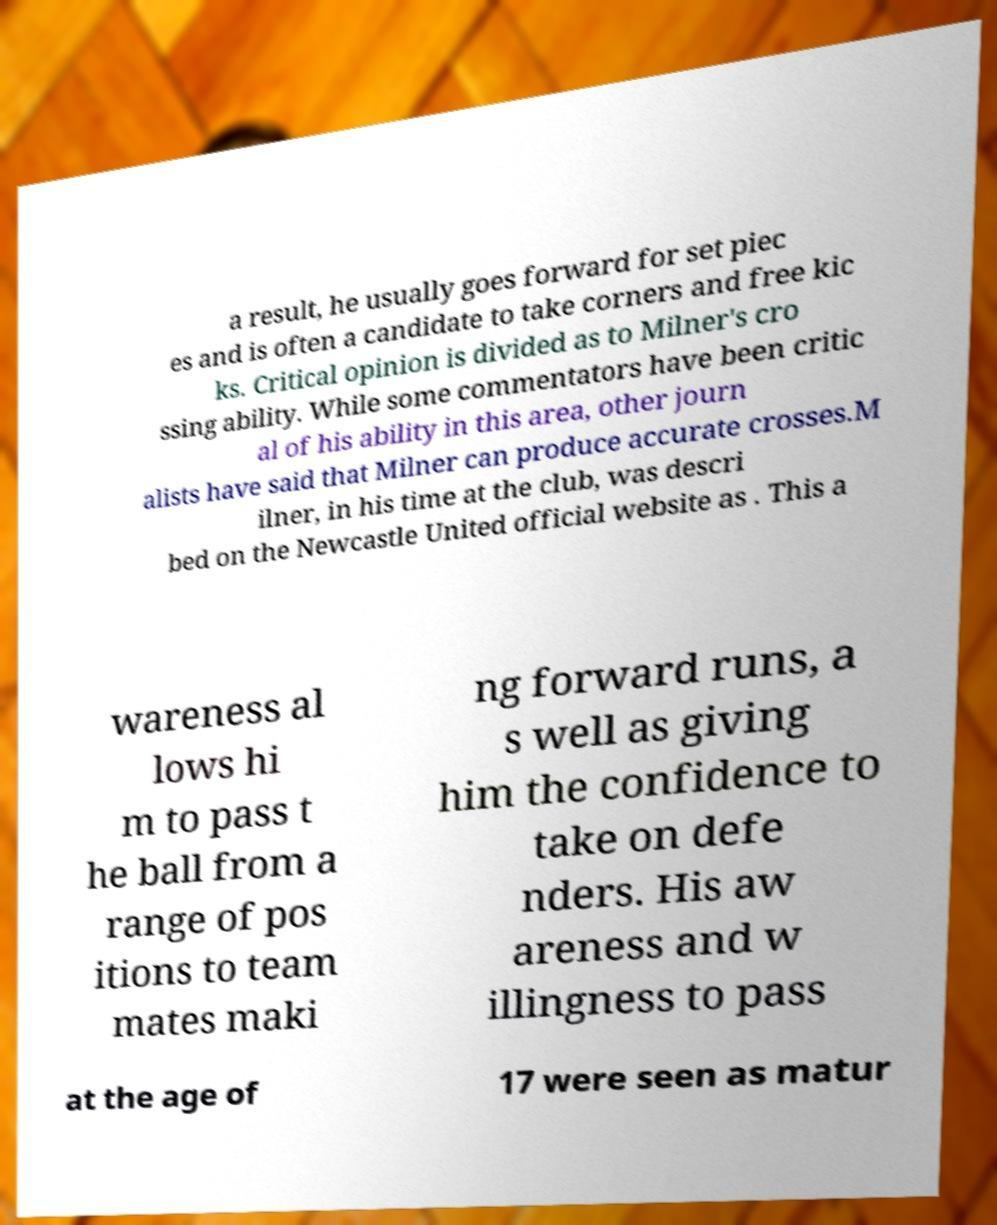What messages or text are displayed in this image? I need them in a readable, typed format. a result, he usually goes forward for set piec es and is often a candidate to take corners and free kic ks. Critical opinion is divided as to Milner's cro ssing ability. While some commentators have been critic al of his ability in this area, other journ alists have said that Milner can produce accurate crosses.M ilner, in his time at the club, was descri bed on the Newcastle United official website as . This a wareness al lows hi m to pass t he ball from a range of pos itions to team mates maki ng forward runs, a s well as giving him the confidence to take on defe nders. His aw areness and w illingness to pass at the age of 17 were seen as matur 